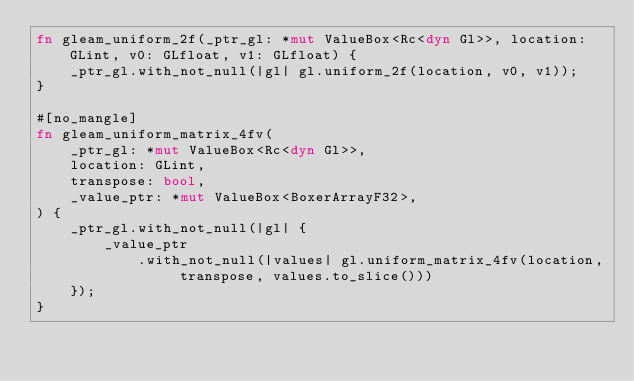Convert code to text. <code><loc_0><loc_0><loc_500><loc_500><_Rust_>fn gleam_uniform_2f(_ptr_gl: *mut ValueBox<Rc<dyn Gl>>, location: GLint, v0: GLfloat, v1: GLfloat) {
    _ptr_gl.with_not_null(|gl| gl.uniform_2f(location, v0, v1));
}

#[no_mangle]
fn gleam_uniform_matrix_4fv(
    _ptr_gl: *mut ValueBox<Rc<dyn Gl>>,
    location: GLint,
    transpose: bool,
    _value_ptr: *mut ValueBox<BoxerArrayF32>,
) {
    _ptr_gl.with_not_null(|gl| {
        _value_ptr
            .with_not_null(|values| gl.uniform_matrix_4fv(location, transpose, values.to_slice()))
    });
}
</code> 